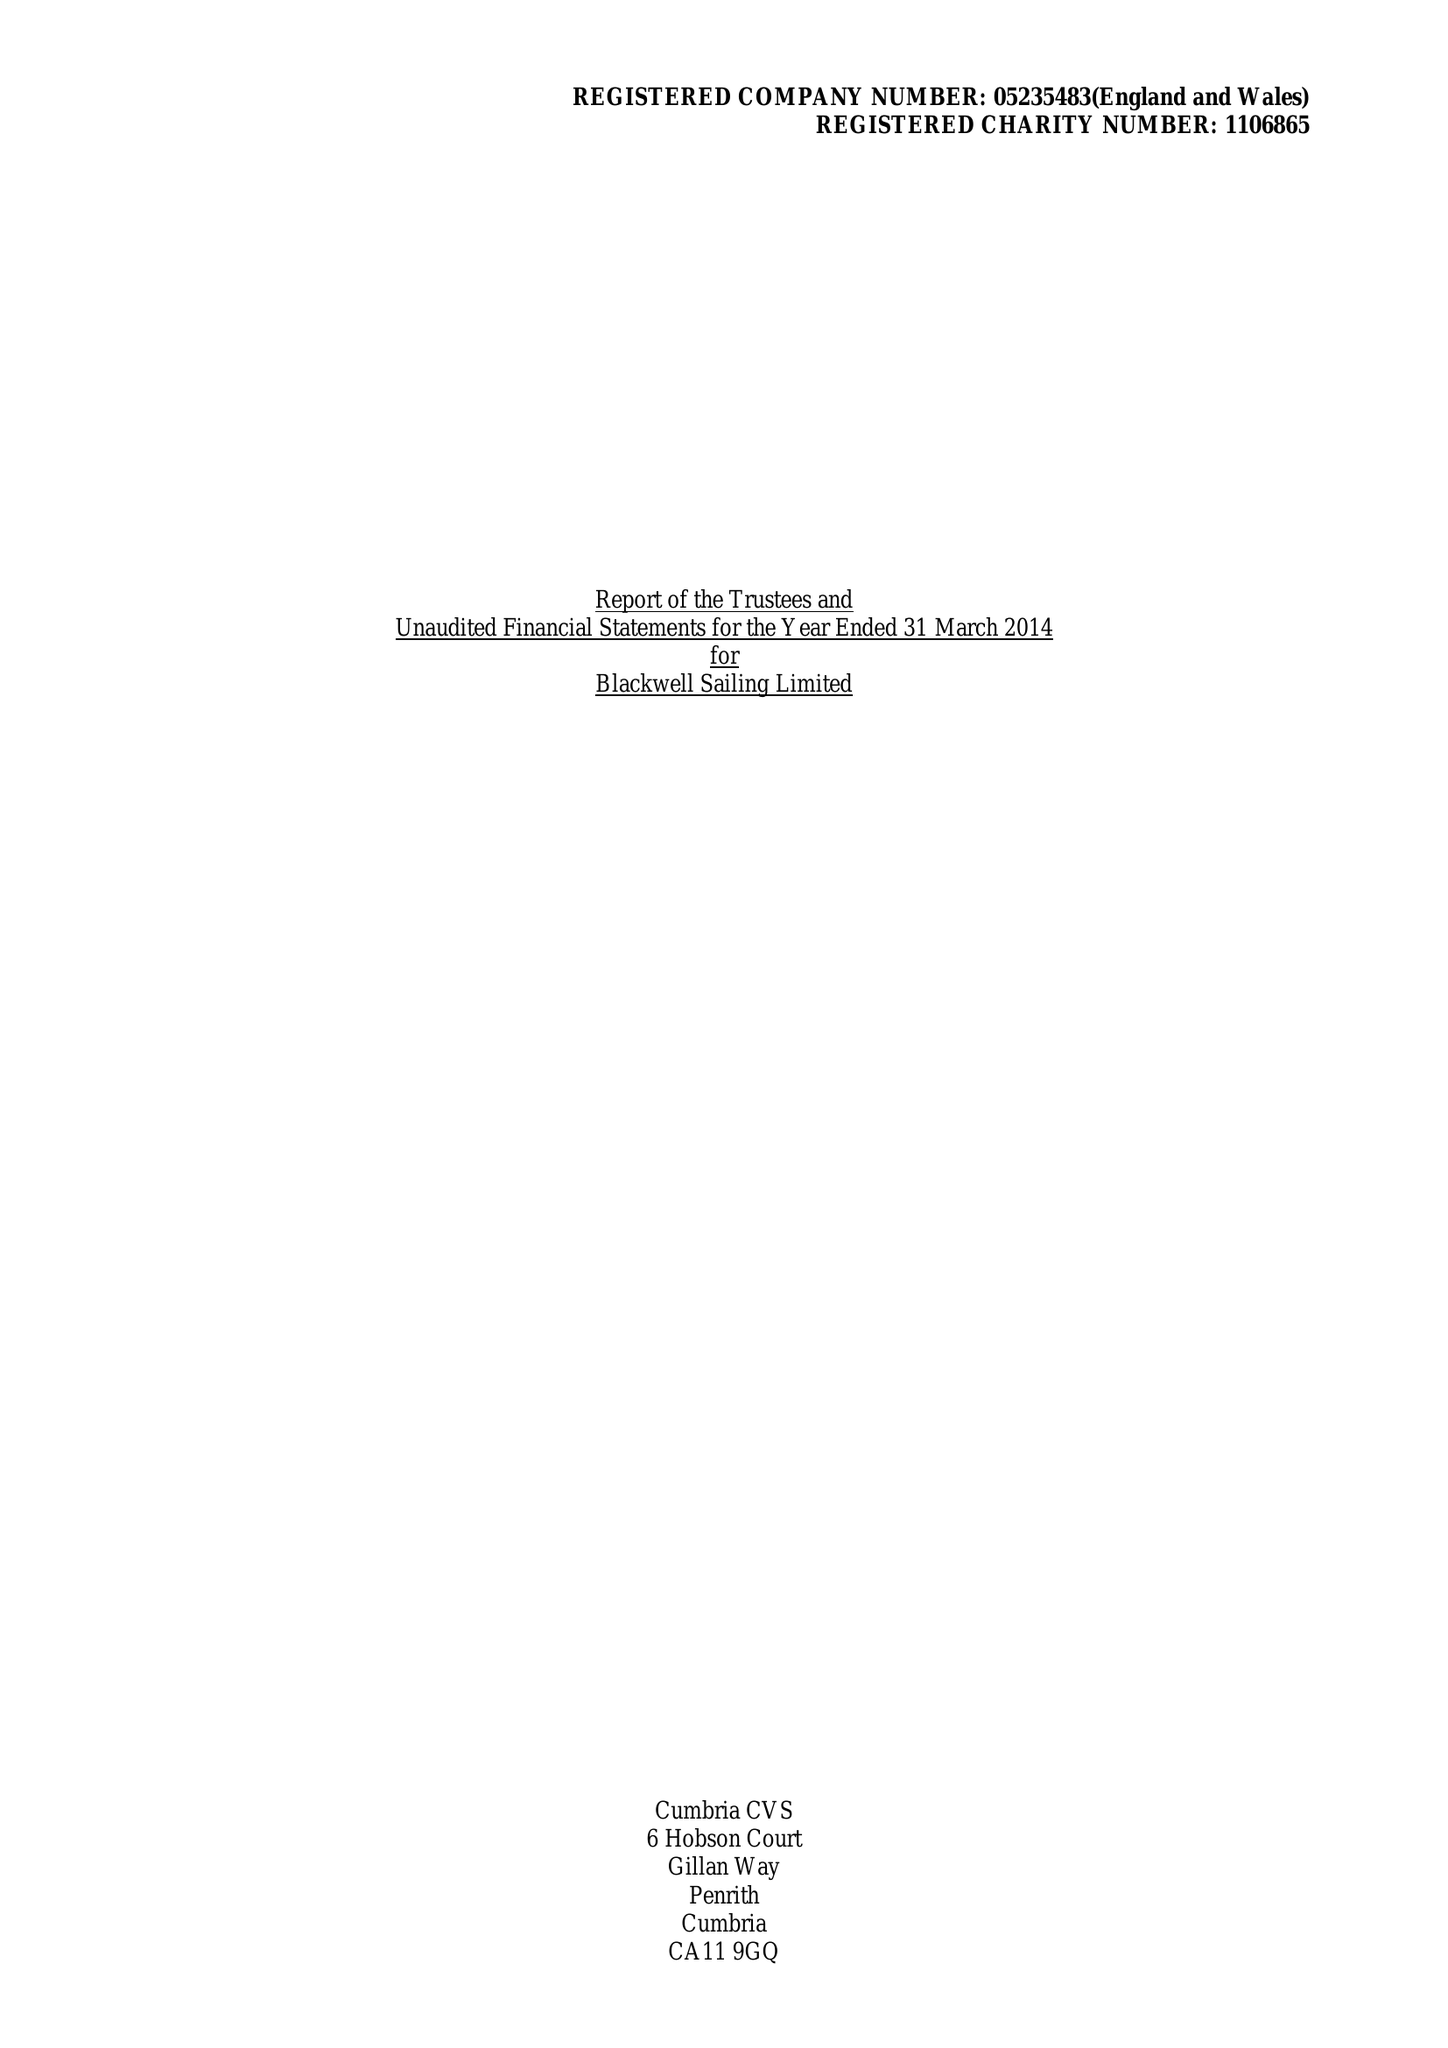What is the value for the report_date?
Answer the question using a single word or phrase. 2014-03-31 